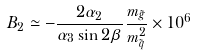Convert formula to latex. <formula><loc_0><loc_0><loc_500><loc_500>B _ { 2 } \simeq - \frac { 2 \alpha _ { 2 } } { \alpha _ { 3 } \sin 2 \beta } \frac { m _ { \tilde { g } } } { m _ { \tilde { q } } ^ { 2 } } \times 1 0 ^ { 6 }</formula> 